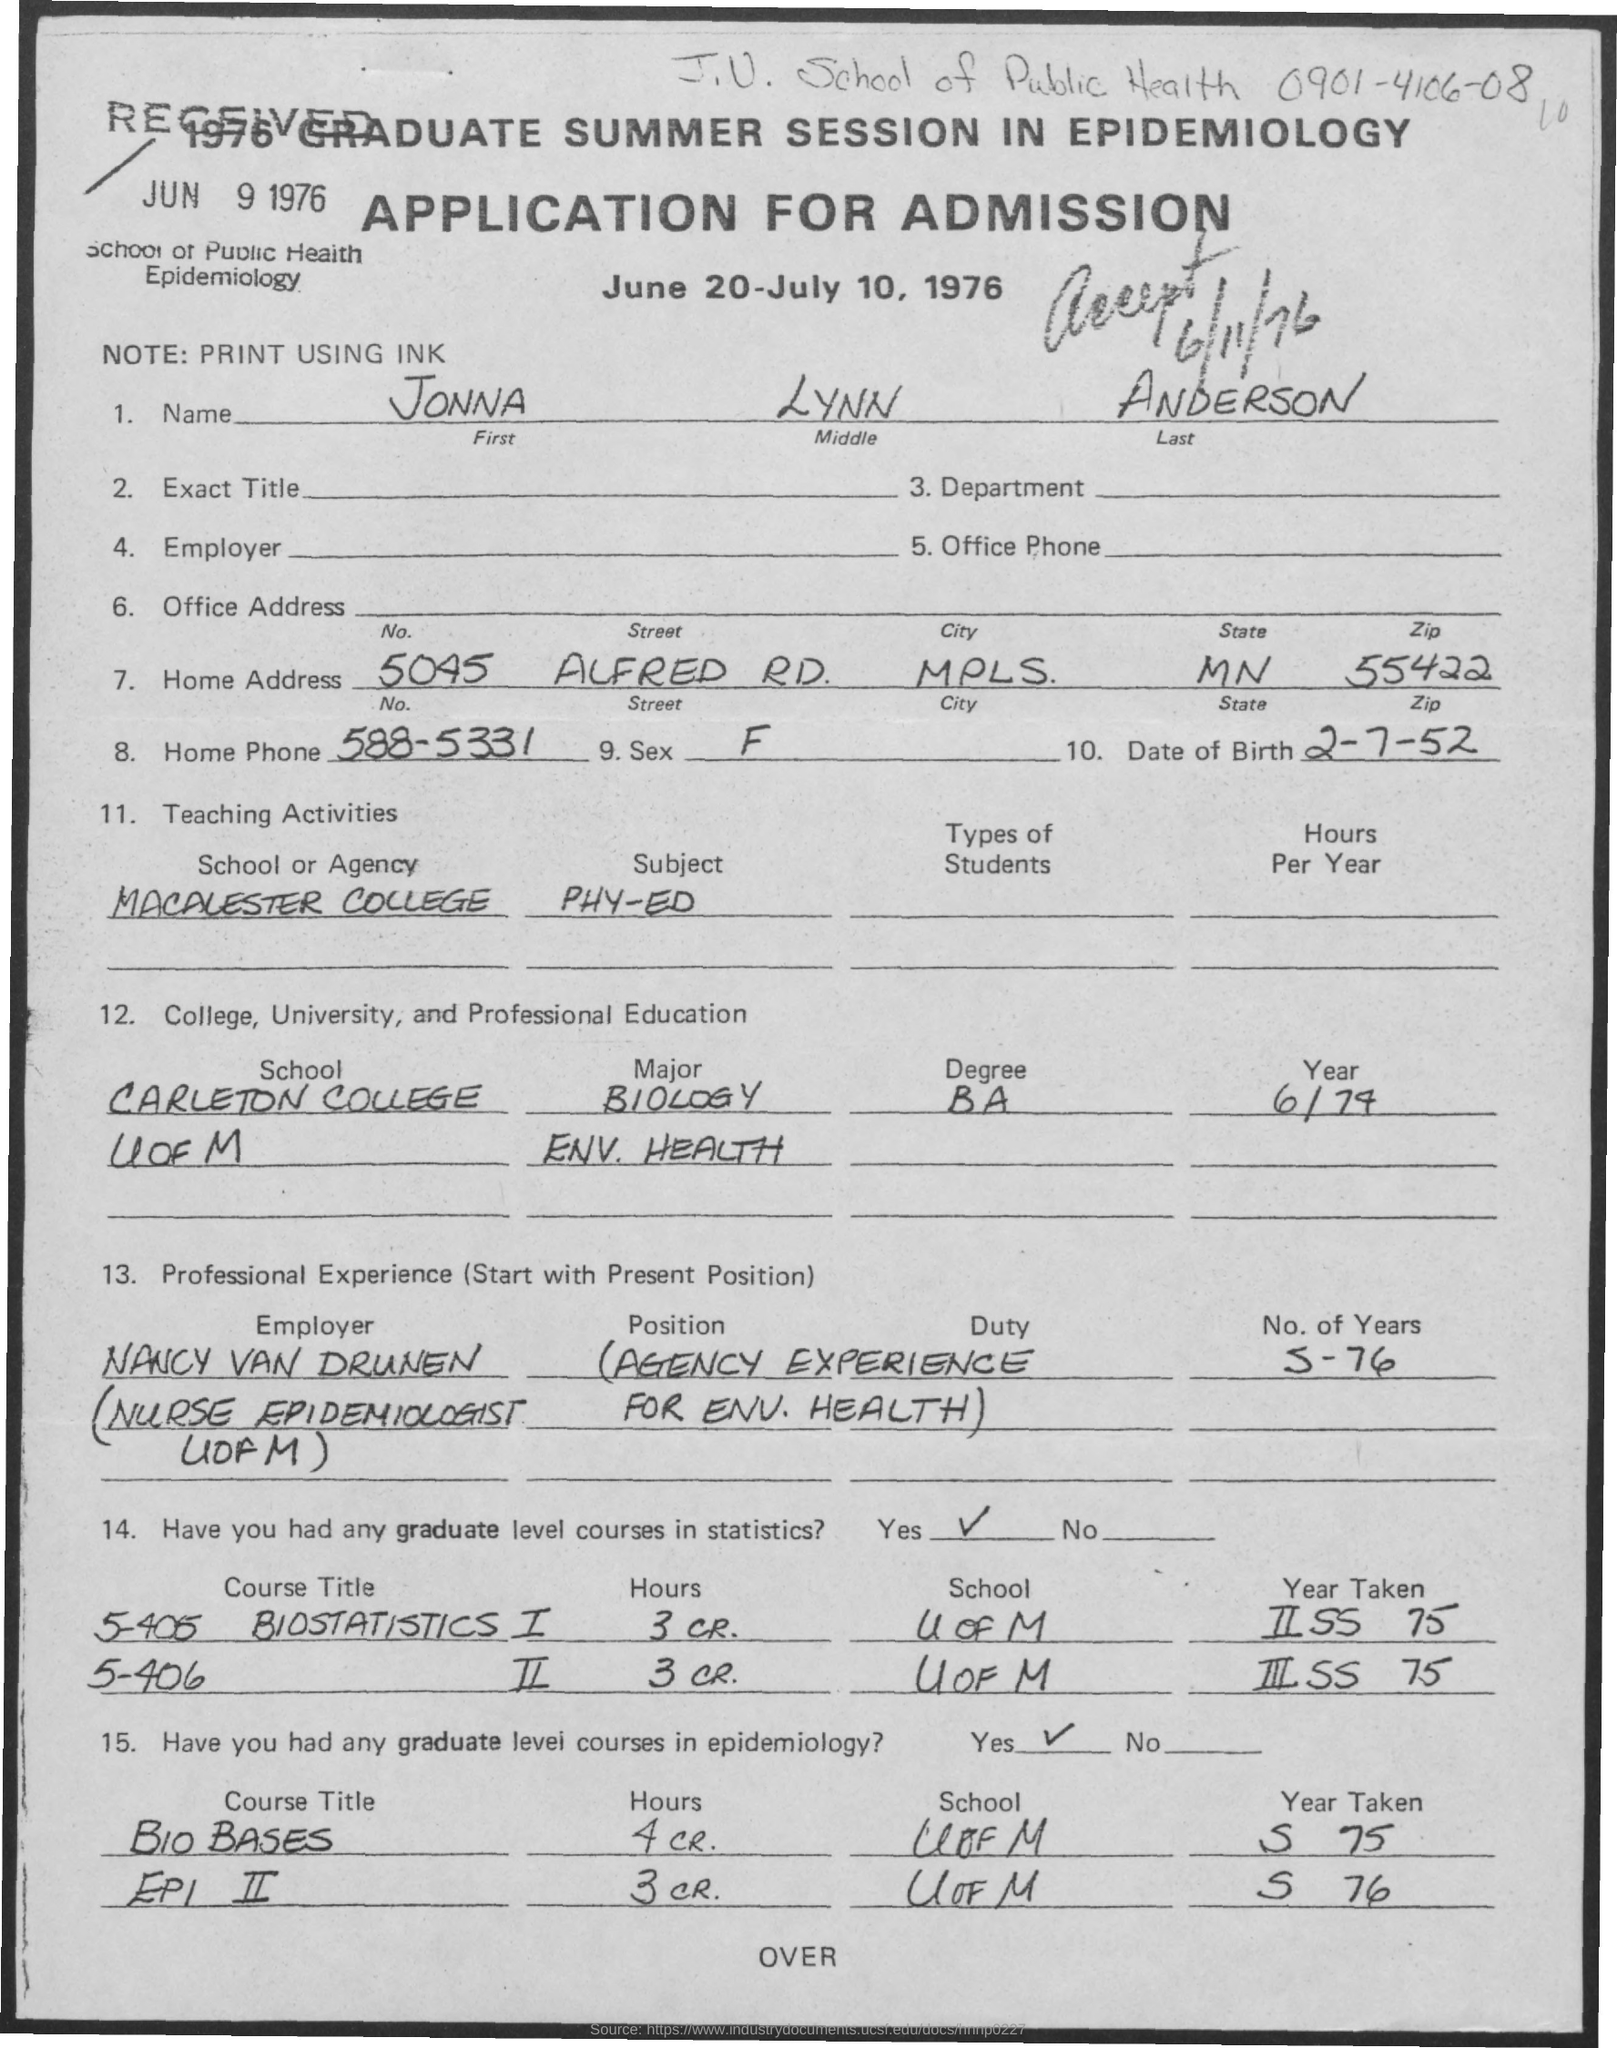Mention a couple of crucial points in this snapshot. The first name is Jonna. The last name of Anderson has been declared. The middle name of the person is Lynn. The date of birth is June 2, 1952. The home phone number is 588-5331. 